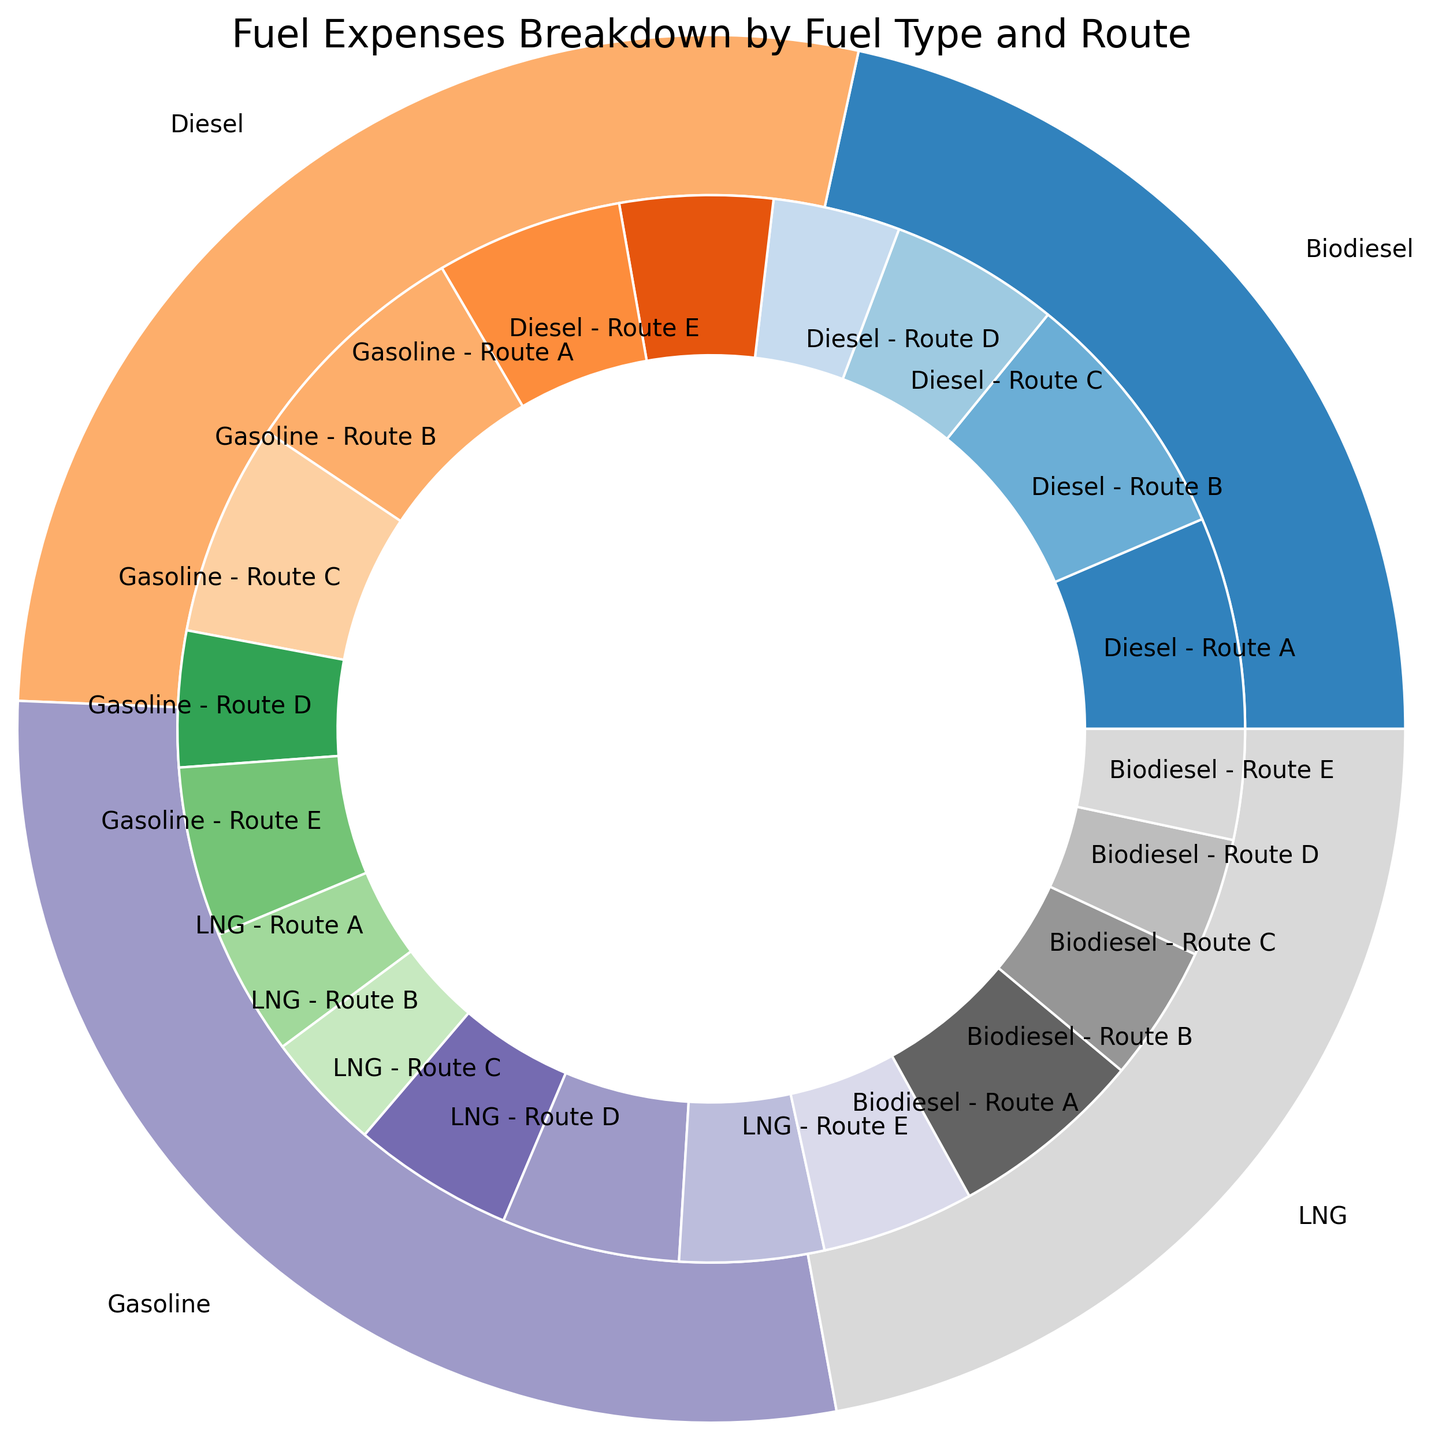What's the total expense for Diesel and Gasoline combined? First, find the total expense for Diesel, which is the sum of expenses across all routes: 25000 + 30000 + 20000 + 15000 + 18000 = 108000. Then, find the total expense for Gasoline: 22000 + 28000 + 25000 + 16000 + 20000 = 111000. Adding these together: 108000 + 111000 = 219000.
Answer: 219000 Which fuel type has the lowest total expense? Comparing the total expenses for each fuel type: Diesel (108000), Gasoline (111000), LNG (86000), and Biodiesel (84000). Biodiesel has the lowest total expense.
Answer: Biodiesel What is the expense for Route C compared to Route E for Gasoline? The expense for Route C for Gasoline is 25000, and for Route E it is 20000. Comparing these, 25000 is greater than 20000.
Answer: Route C > Route E How does the expense for Diesel on Route A compare to LNG on the same route? The expense for Diesel on Route A is 25000. For LNG on Route A, it is 15000. Therefore, 25000 is greater than 15000.
Answer: Diesel > LNG Which fuel type has the highest expense on Route D? Looking at the expenses for Route D: Diesel (15000), Gasoline (16000), LNG (21000), and Biodiesel (14000). LNG has the highest expense for Route D.
Answer: LNG What's the difference in total expense between Diesel and Biodiesel? The total expense for Diesel is 108000. For Biodiesel, it is 84000. The difference is 108000 - 84000 = 24000.
Answer: 24000 What's the sum of expenses for LNG across all routes? Summing up the expenses for LNG across all routes: 15000 + 14000 + 19000 + 21000 + 17000 = 86000.
Answer: 86000 Which route has the highest total expense when combining all fuel types? Summing up expenses for each route: Route A (25000 + 22000 + 15000 + 18000 = 80000), Route B (30000 + 28000 + 14000 + 23000 = 95000), Route C (20000 + 25000 + 19000 + 16000 = 80000), Route D (15000 + 16000 + 21000 + 14000 = 66000), Route E (18000 + 20000 + 17000 + 13000 = 68000). Route B has the highest total expense at 95000.
Answer: Route B What percentage of the total expense does Diesel represent? The total expense across all fuel types is 108000 (Diesel) + 111000 (Gasoline) + 86000 (LNG) + 84000 (Biodiesel) = 389000. The percentage for Diesel is (108000 / 389000) * 100 ≈ 27.8%.
Answer: 27.8% Compare the expense for Route D between all fuel types, and identify which fuel type has the second-highest expense. The expenses for Route D are Diesel (15000), Gasoline (16000), LNG (21000), and Biodiesel (14000). Sorting these expenses in descending order: LNG (21000), Gasoline (16000), Diesel (15000), and Biodiesel (14000). Gasoline has the second-highest expense.
Answer: Gasoline 